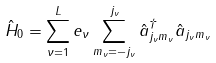Convert formula to latex. <formula><loc_0><loc_0><loc_500><loc_500>\hat { H } _ { 0 } = \sum _ { \nu = 1 } ^ { L } e _ { \nu } \sum _ { m _ { \nu } = - j _ { \nu } } ^ { j _ { \nu } } \hat { a } ^ { \dagger } _ { j _ { \nu } m _ { \nu } } \hat { a } _ { j _ { \nu } m _ { \nu } }</formula> 